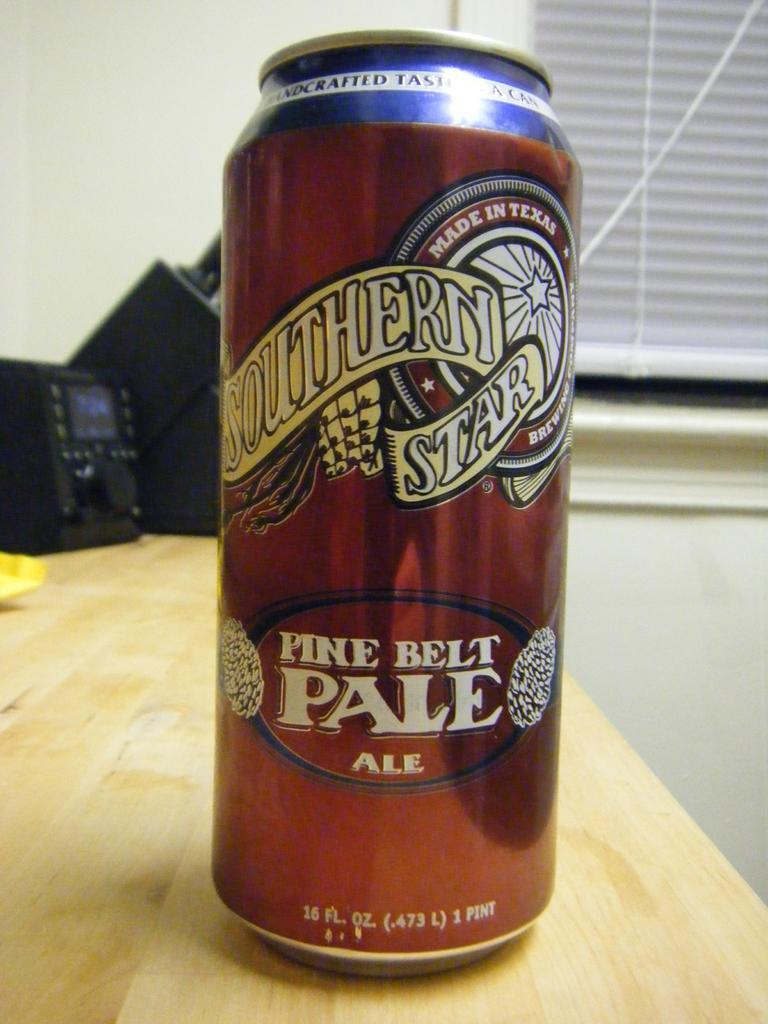<image>
Provide a brief description of the given image. A can of Southern Star Pine Belt Pale Ale in a red can on a table. 